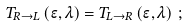Convert formula to latex. <formula><loc_0><loc_0><loc_500><loc_500>T _ { R \rightarrow L } \left ( \epsilon , \lambda \right ) = T _ { L \rightarrow R } \left ( \epsilon , \lambda \right ) \, ;</formula> 